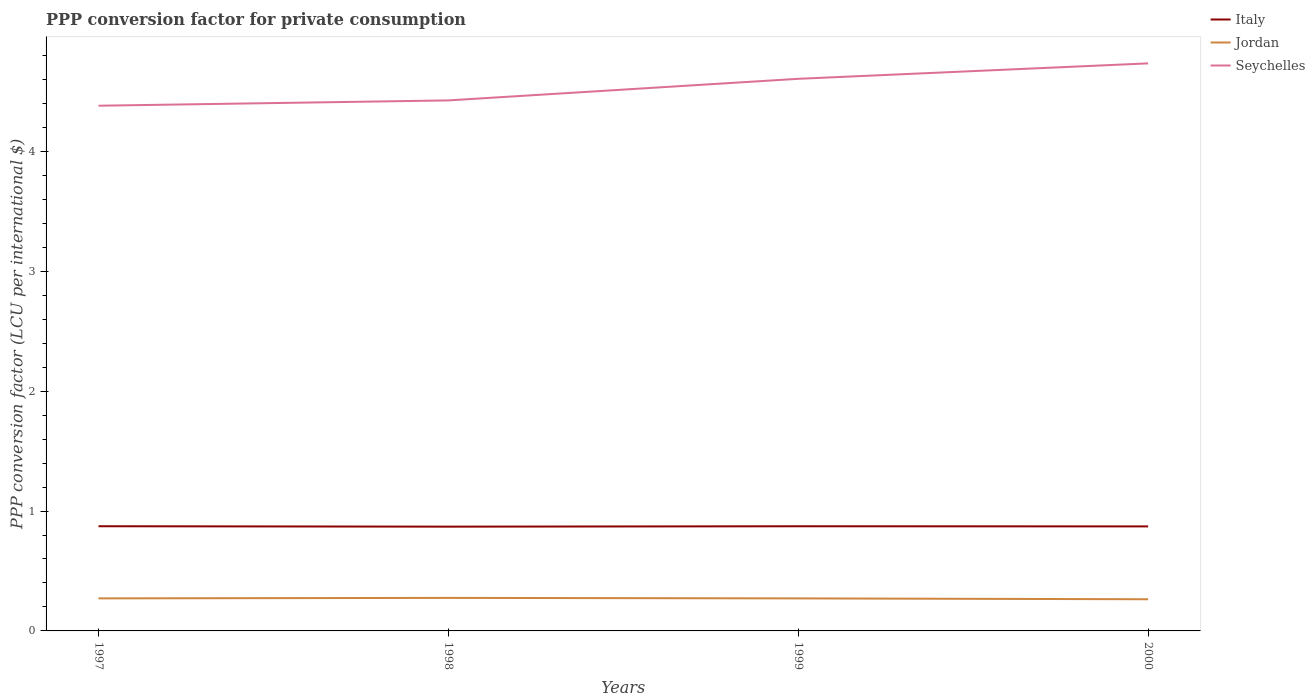Is the number of lines equal to the number of legend labels?
Ensure brevity in your answer.  Yes. Across all years, what is the maximum PPP conversion factor for private consumption in Italy?
Ensure brevity in your answer.  0.87. What is the total PPP conversion factor for private consumption in Italy in the graph?
Ensure brevity in your answer.  -0. What is the difference between the highest and the second highest PPP conversion factor for private consumption in Jordan?
Your answer should be very brief. 0.01. Is the PPP conversion factor for private consumption in Italy strictly greater than the PPP conversion factor for private consumption in Seychelles over the years?
Give a very brief answer. Yes. How many years are there in the graph?
Offer a terse response. 4. Are the values on the major ticks of Y-axis written in scientific E-notation?
Provide a succinct answer. No. Does the graph contain grids?
Offer a terse response. No. Where does the legend appear in the graph?
Your response must be concise. Top right. How many legend labels are there?
Your response must be concise. 3. How are the legend labels stacked?
Offer a very short reply. Vertical. What is the title of the graph?
Give a very brief answer. PPP conversion factor for private consumption. Does "Marshall Islands" appear as one of the legend labels in the graph?
Offer a very short reply. No. What is the label or title of the X-axis?
Provide a succinct answer. Years. What is the label or title of the Y-axis?
Ensure brevity in your answer.  PPP conversion factor (LCU per international $). What is the PPP conversion factor (LCU per international $) of Italy in 1997?
Provide a succinct answer. 0.87. What is the PPP conversion factor (LCU per international $) in Jordan in 1997?
Give a very brief answer. 0.27. What is the PPP conversion factor (LCU per international $) in Seychelles in 1997?
Your answer should be compact. 4.38. What is the PPP conversion factor (LCU per international $) in Italy in 1998?
Your response must be concise. 0.87. What is the PPP conversion factor (LCU per international $) in Jordan in 1998?
Offer a terse response. 0.28. What is the PPP conversion factor (LCU per international $) of Seychelles in 1998?
Ensure brevity in your answer.  4.43. What is the PPP conversion factor (LCU per international $) in Italy in 1999?
Your answer should be compact. 0.87. What is the PPP conversion factor (LCU per international $) of Jordan in 1999?
Offer a terse response. 0.27. What is the PPP conversion factor (LCU per international $) in Seychelles in 1999?
Keep it short and to the point. 4.61. What is the PPP conversion factor (LCU per international $) of Italy in 2000?
Offer a terse response. 0.87. What is the PPP conversion factor (LCU per international $) in Jordan in 2000?
Offer a very short reply. 0.26. What is the PPP conversion factor (LCU per international $) of Seychelles in 2000?
Make the answer very short. 4.73. Across all years, what is the maximum PPP conversion factor (LCU per international $) of Italy?
Provide a succinct answer. 0.87. Across all years, what is the maximum PPP conversion factor (LCU per international $) in Jordan?
Provide a short and direct response. 0.28. Across all years, what is the maximum PPP conversion factor (LCU per international $) of Seychelles?
Provide a succinct answer. 4.73. Across all years, what is the minimum PPP conversion factor (LCU per international $) in Italy?
Give a very brief answer. 0.87. Across all years, what is the minimum PPP conversion factor (LCU per international $) of Jordan?
Provide a succinct answer. 0.26. Across all years, what is the minimum PPP conversion factor (LCU per international $) in Seychelles?
Your response must be concise. 4.38. What is the total PPP conversion factor (LCU per international $) in Italy in the graph?
Offer a very short reply. 3.49. What is the total PPP conversion factor (LCU per international $) of Jordan in the graph?
Give a very brief answer. 1.08. What is the total PPP conversion factor (LCU per international $) of Seychelles in the graph?
Your answer should be very brief. 18.14. What is the difference between the PPP conversion factor (LCU per international $) of Italy in 1997 and that in 1998?
Keep it short and to the point. 0. What is the difference between the PPP conversion factor (LCU per international $) of Jordan in 1997 and that in 1998?
Your answer should be very brief. -0. What is the difference between the PPP conversion factor (LCU per international $) of Seychelles in 1997 and that in 1998?
Offer a very short reply. -0.04. What is the difference between the PPP conversion factor (LCU per international $) of Seychelles in 1997 and that in 1999?
Provide a succinct answer. -0.22. What is the difference between the PPP conversion factor (LCU per international $) of Italy in 1997 and that in 2000?
Offer a very short reply. 0. What is the difference between the PPP conversion factor (LCU per international $) of Jordan in 1997 and that in 2000?
Your response must be concise. 0.01. What is the difference between the PPP conversion factor (LCU per international $) of Seychelles in 1997 and that in 2000?
Give a very brief answer. -0.35. What is the difference between the PPP conversion factor (LCU per international $) in Italy in 1998 and that in 1999?
Provide a succinct answer. -0. What is the difference between the PPP conversion factor (LCU per international $) of Jordan in 1998 and that in 1999?
Provide a short and direct response. 0. What is the difference between the PPP conversion factor (LCU per international $) in Seychelles in 1998 and that in 1999?
Offer a very short reply. -0.18. What is the difference between the PPP conversion factor (LCU per international $) in Italy in 1998 and that in 2000?
Make the answer very short. -0. What is the difference between the PPP conversion factor (LCU per international $) of Jordan in 1998 and that in 2000?
Provide a succinct answer. 0.01. What is the difference between the PPP conversion factor (LCU per international $) in Seychelles in 1998 and that in 2000?
Offer a terse response. -0.31. What is the difference between the PPP conversion factor (LCU per international $) of Italy in 1999 and that in 2000?
Offer a very short reply. 0. What is the difference between the PPP conversion factor (LCU per international $) in Jordan in 1999 and that in 2000?
Provide a succinct answer. 0.01. What is the difference between the PPP conversion factor (LCU per international $) in Seychelles in 1999 and that in 2000?
Your response must be concise. -0.13. What is the difference between the PPP conversion factor (LCU per international $) in Italy in 1997 and the PPP conversion factor (LCU per international $) in Jordan in 1998?
Your response must be concise. 0.6. What is the difference between the PPP conversion factor (LCU per international $) in Italy in 1997 and the PPP conversion factor (LCU per international $) in Seychelles in 1998?
Offer a terse response. -3.55. What is the difference between the PPP conversion factor (LCU per international $) in Jordan in 1997 and the PPP conversion factor (LCU per international $) in Seychelles in 1998?
Give a very brief answer. -4.15. What is the difference between the PPP conversion factor (LCU per international $) of Italy in 1997 and the PPP conversion factor (LCU per international $) of Jordan in 1999?
Your response must be concise. 0.6. What is the difference between the PPP conversion factor (LCU per international $) of Italy in 1997 and the PPP conversion factor (LCU per international $) of Seychelles in 1999?
Ensure brevity in your answer.  -3.73. What is the difference between the PPP conversion factor (LCU per international $) of Jordan in 1997 and the PPP conversion factor (LCU per international $) of Seychelles in 1999?
Offer a terse response. -4.33. What is the difference between the PPP conversion factor (LCU per international $) in Italy in 1997 and the PPP conversion factor (LCU per international $) in Jordan in 2000?
Your answer should be very brief. 0.61. What is the difference between the PPP conversion factor (LCU per international $) in Italy in 1997 and the PPP conversion factor (LCU per international $) in Seychelles in 2000?
Provide a short and direct response. -3.86. What is the difference between the PPP conversion factor (LCU per international $) in Jordan in 1997 and the PPP conversion factor (LCU per international $) in Seychelles in 2000?
Your response must be concise. -4.46. What is the difference between the PPP conversion factor (LCU per international $) of Italy in 1998 and the PPP conversion factor (LCU per international $) of Jordan in 1999?
Your answer should be very brief. 0.6. What is the difference between the PPP conversion factor (LCU per international $) in Italy in 1998 and the PPP conversion factor (LCU per international $) in Seychelles in 1999?
Your answer should be very brief. -3.74. What is the difference between the PPP conversion factor (LCU per international $) of Jordan in 1998 and the PPP conversion factor (LCU per international $) of Seychelles in 1999?
Provide a succinct answer. -4.33. What is the difference between the PPP conversion factor (LCU per international $) of Italy in 1998 and the PPP conversion factor (LCU per international $) of Jordan in 2000?
Provide a succinct answer. 0.61. What is the difference between the PPP conversion factor (LCU per international $) of Italy in 1998 and the PPP conversion factor (LCU per international $) of Seychelles in 2000?
Make the answer very short. -3.86. What is the difference between the PPP conversion factor (LCU per international $) of Jordan in 1998 and the PPP conversion factor (LCU per international $) of Seychelles in 2000?
Offer a terse response. -4.46. What is the difference between the PPP conversion factor (LCU per international $) of Italy in 1999 and the PPP conversion factor (LCU per international $) of Jordan in 2000?
Keep it short and to the point. 0.61. What is the difference between the PPP conversion factor (LCU per international $) in Italy in 1999 and the PPP conversion factor (LCU per international $) in Seychelles in 2000?
Give a very brief answer. -3.86. What is the difference between the PPP conversion factor (LCU per international $) in Jordan in 1999 and the PPP conversion factor (LCU per international $) in Seychelles in 2000?
Offer a very short reply. -4.46. What is the average PPP conversion factor (LCU per international $) of Italy per year?
Your response must be concise. 0.87. What is the average PPP conversion factor (LCU per international $) of Jordan per year?
Give a very brief answer. 0.27. What is the average PPP conversion factor (LCU per international $) of Seychelles per year?
Provide a short and direct response. 4.54. In the year 1997, what is the difference between the PPP conversion factor (LCU per international $) of Italy and PPP conversion factor (LCU per international $) of Jordan?
Offer a terse response. 0.6. In the year 1997, what is the difference between the PPP conversion factor (LCU per international $) of Italy and PPP conversion factor (LCU per international $) of Seychelles?
Make the answer very short. -3.51. In the year 1997, what is the difference between the PPP conversion factor (LCU per international $) of Jordan and PPP conversion factor (LCU per international $) of Seychelles?
Provide a succinct answer. -4.11. In the year 1998, what is the difference between the PPP conversion factor (LCU per international $) of Italy and PPP conversion factor (LCU per international $) of Jordan?
Your answer should be compact. 0.59. In the year 1998, what is the difference between the PPP conversion factor (LCU per international $) in Italy and PPP conversion factor (LCU per international $) in Seychelles?
Keep it short and to the point. -3.56. In the year 1998, what is the difference between the PPP conversion factor (LCU per international $) of Jordan and PPP conversion factor (LCU per international $) of Seychelles?
Make the answer very short. -4.15. In the year 1999, what is the difference between the PPP conversion factor (LCU per international $) of Italy and PPP conversion factor (LCU per international $) of Jordan?
Ensure brevity in your answer.  0.6. In the year 1999, what is the difference between the PPP conversion factor (LCU per international $) in Italy and PPP conversion factor (LCU per international $) in Seychelles?
Ensure brevity in your answer.  -3.73. In the year 1999, what is the difference between the PPP conversion factor (LCU per international $) in Jordan and PPP conversion factor (LCU per international $) in Seychelles?
Provide a succinct answer. -4.33. In the year 2000, what is the difference between the PPP conversion factor (LCU per international $) of Italy and PPP conversion factor (LCU per international $) of Jordan?
Offer a terse response. 0.61. In the year 2000, what is the difference between the PPP conversion factor (LCU per international $) of Italy and PPP conversion factor (LCU per international $) of Seychelles?
Make the answer very short. -3.86. In the year 2000, what is the difference between the PPP conversion factor (LCU per international $) in Jordan and PPP conversion factor (LCU per international $) in Seychelles?
Your answer should be compact. -4.47. What is the ratio of the PPP conversion factor (LCU per international $) in Italy in 1997 to that in 1998?
Give a very brief answer. 1. What is the ratio of the PPP conversion factor (LCU per international $) in Jordan in 1997 to that in 1998?
Provide a succinct answer. 0.99. What is the ratio of the PPP conversion factor (LCU per international $) in Seychelles in 1997 to that in 1998?
Ensure brevity in your answer.  0.99. What is the ratio of the PPP conversion factor (LCU per international $) of Italy in 1997 to that in 1999?
Your response must be concise. 1. What is the ratio of the PPP conversion factor (LCU per international $) of Seychelles in 1997 to that in 1999?
Give a very brief answer. 0.95. What is the ratio of the PPP conversion factor (LCU per international $) in Jordan in 1997 to that in 2000?
Offer a very short reply. 1.03. What is the ratio of the PPP conversion factor (LCU per international $) in Seychelles in 1997 to that in 2000?
Give a very brief answer. 0.93. What is the ratio of the PPP conversion factor (LCU per international $) of Italy in 1998 to that in 1999?
Your response must be concise. 1. What is the ratio of the PPP conversion factor (LCU per international $) of Jordan in 1998 to that in 1999?
Make the answer very short. 1.02. What is the ratio of the PPP conversion factor (LCU per international $) of Seychelles in 1998 to that in 1999?
Provide a succinct answer. 0.96. What is the ratio of the PPP conversion factor (LCU per international $) in Jordan in 1998 to that in 2000?
Make the answer very short. 1.04. What is the ratio of the PPP conversion factor (LCU per international $) in Seychelles in 1998 to that in 2000?
Keep it short and to the point. 0.93. What is the ratio of the PPP conversion factor (LCU per international $) of Jordan in 1999 to that in 2000?
Ensure brevity in your answer.  1.03. What is the ratio of the PPP conversion factor (LCU per international $) of Seychelles in 1999 to that in 2000?
Offer a very short reply. 0.97. What is the difference between the highest and the second highest PPP conversion factor (LCU per international $) of Italy?
Keep it short and to the point. 0. What is the difference between the highest and the second highest PPP conversion factor (LCU per international $) in Jordan?
Keep it short and to the point. 0. What is the difference between the highest and the second highest PPP conversion factor (LCU per international $) of Seychelles?
Your answer should be compact. 0.13. What is the difference between the highest and the lowest PPP conversion factor (LCU per international $) of Italy?
Provide a succinct answer. 0. What is the difference between the highest and the lowest PPP conversion factor (LCU per international $) of Jordan?
Ensure brevity in your answer.  0.01. What is the difference between the highest and the lowest PPP conversion factor (LCU per international $) of Seychelles?
Keep it short and to the point. 0.35. 